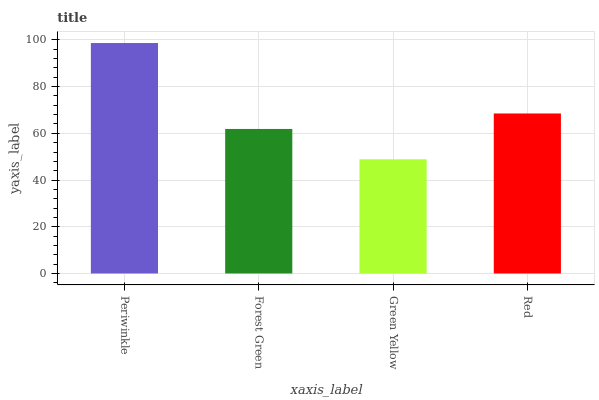Is Green Yellow the minimum?
Answer yes or no. Yes. Is Periwinkle the maximum?
Answer yes or no. Yes. Is Forest Green the minimum?
Answer yes or no. No. Is Forest Green the maximum?
Answer yes or no. No. Is Periwinkle greater than Forest Green?
Answer yes or no. Yes. Is Forest Green less than Periwinkle?
Answer yes or no. Yes. Is Forest Green greater than Periwinkle?
Answer yes or no. No. Is Periwinkle less than Forest Green?
Answer yes or no. No. Is Red the high median?
Answer yes or no. Yes. Is Forest Green the low median?
Answer yes or no. Yes. Is Forest Green the high median?
Answer yes or no. No. Is Red the low median?
Answer yes or no. No. 